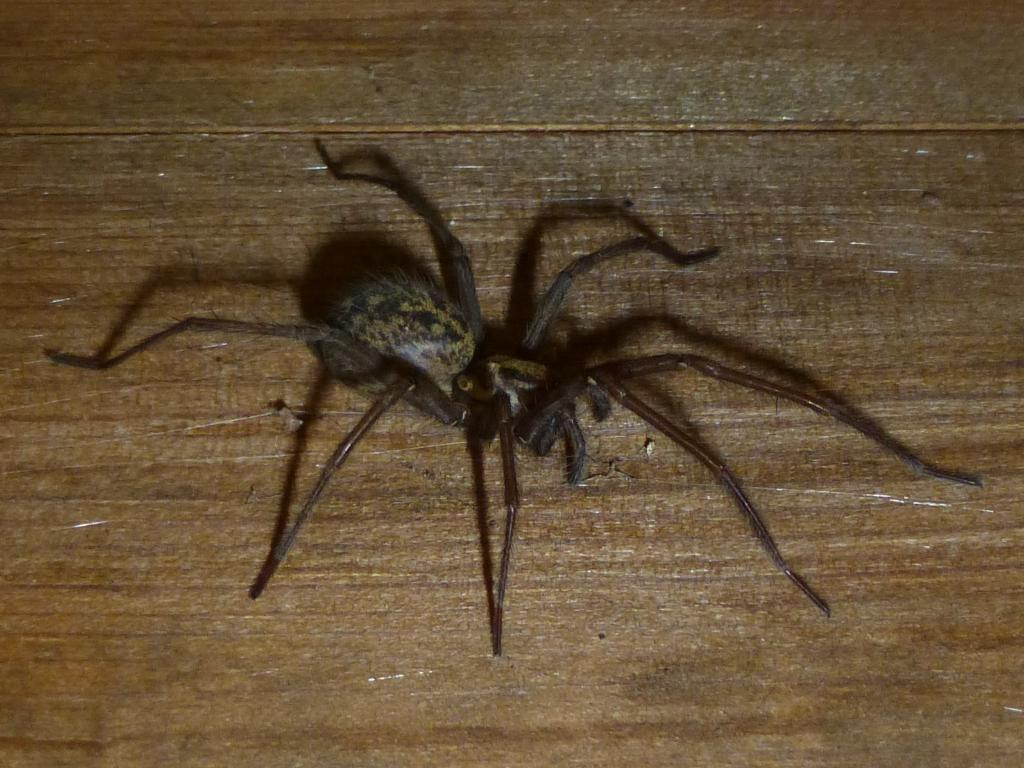What is the main subject of the image? There is a spider in the image. What color is the spider? The spider is black in color. What can be seen in the background of the image? There is a brown table or a wooden wall in the background of the image. What type of advice is the mother giving to the spider in the image? There is no mother or advice present in the image; it only features a black spider. Can you tell me how many gates are visible in the image? There are no gates present in the image; it only features a black spider and a brown table or wooden wall in the background. 